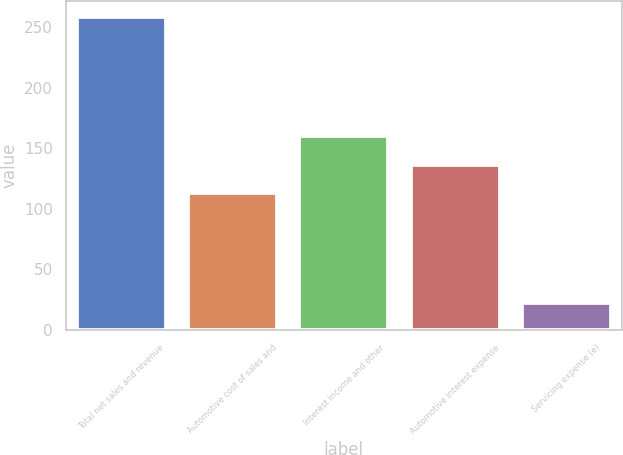Convert chart to OTSL. <chart><loc_0><loc_0><loc_500><loc_500><bar_chart><fcel>Total net sales and revenue<fcel>Automotive cost of sales and<fcel>Interest income and other<fcel>Automotive interest expense<fcel>Servicing expense (e)<nl><fcel>259<fcel>113<fcel>160.4<fcel>136.7<fcel>22<nl></chart> 